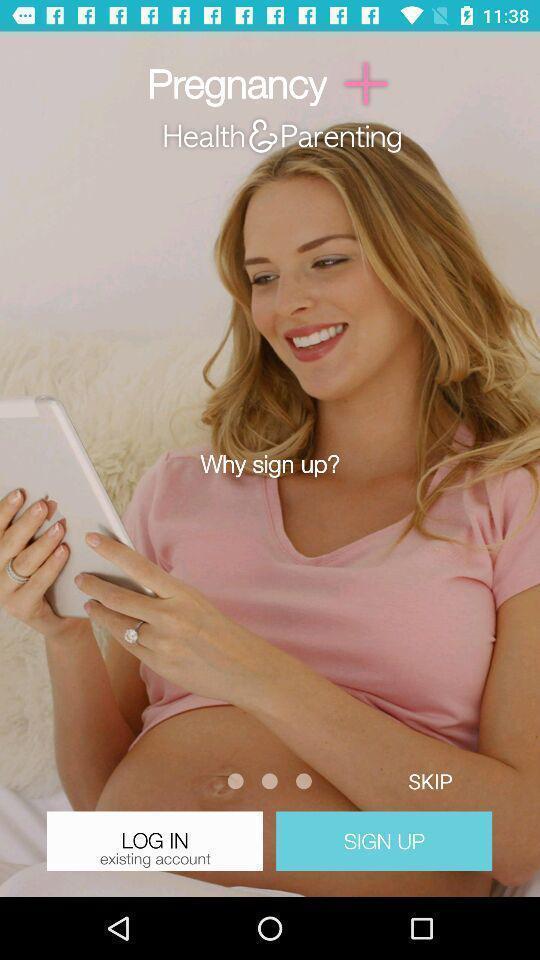Tell me what you see in this picture. Welcome page with options in a pregnancy tracker app. 